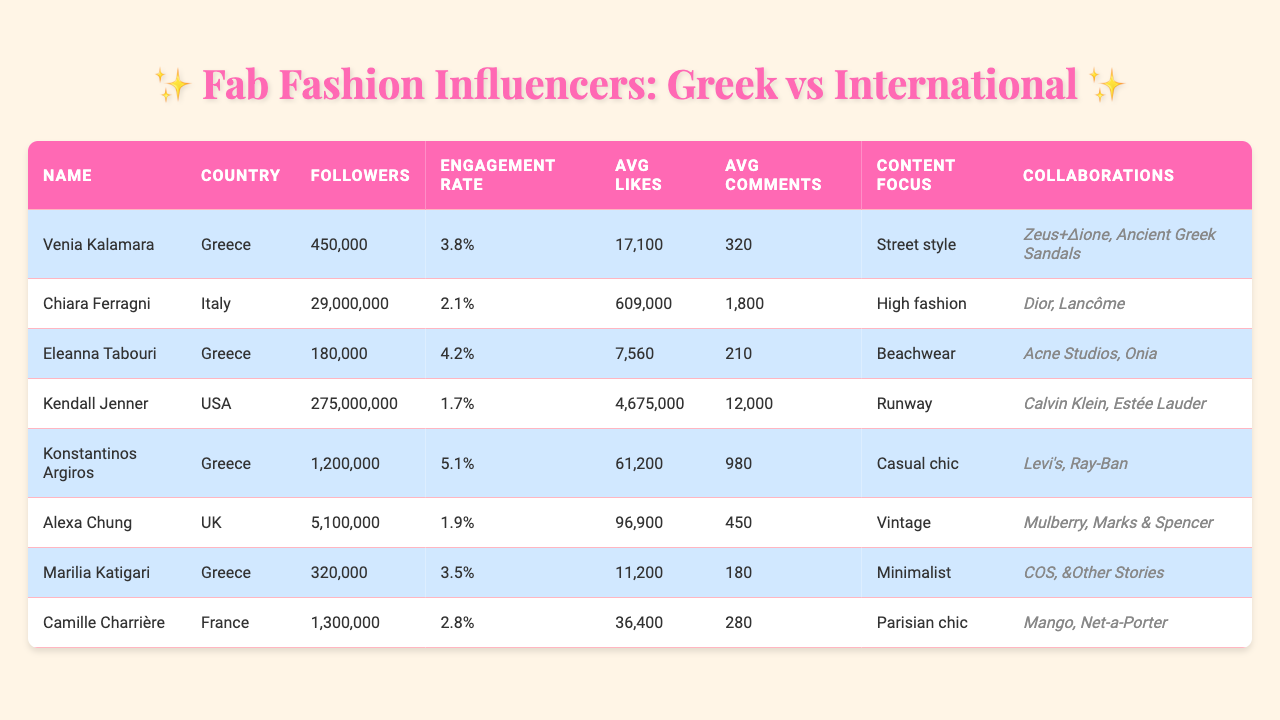What is the engagement rate of Konstantinos Argiros? The table shows that Konstantinos Argiros has an engagement rate of 5.1%.
Answer: 5.1% Which influencer has the highest average likes? By comparing the average likes of each influencer, Kendall Jenner has the highest with 4,675,000 likes per post.
Answer: 4,675,000 How many followers does Eleanna Tabouri have? Eleanna Tabouri is listed with 180,000 followers in the table.
Answer: 180,000 Is Chiara Ferragni's engagement rate higher than Venia Kalamara's? Chiara Ferragni has an engagement rate of 2.1%, while Venia Kalamara has an engagement rate of 3.8%. Since 2.1% is less than 3.8%, the statement is false.
Answer: No What is the average engagement rate of the Greek influencers listed? The engagement rates of Greek influencers are 3.8%, 4.2%, 5.1%, and 3.5%. Summing them up gives 16.6%, and dividing by 4 (the number of influencers) gives an average engagement rate of 4.15%.
Answer: 4.15% Which content focus has the highest engagement rate, and who is the influencer? The table shows Konstantinos Argiros in the "Casual chic" category with the highest engagement rate of 5.1%.
Answer: Casual chic by Konstantinos Argiros Are there any influencers with more than 1 million followers and an engagement rate above 2%? Kendall Jenner and Konstantinos Argiros both have over 1 million followers (275 million and 1.2 million, respectively) and engagement rates of 1.7% and 5.1%. Thus, Konstantinos is the only one meeting this criterion.
Answer: Yes, Konstantinos Argiros 